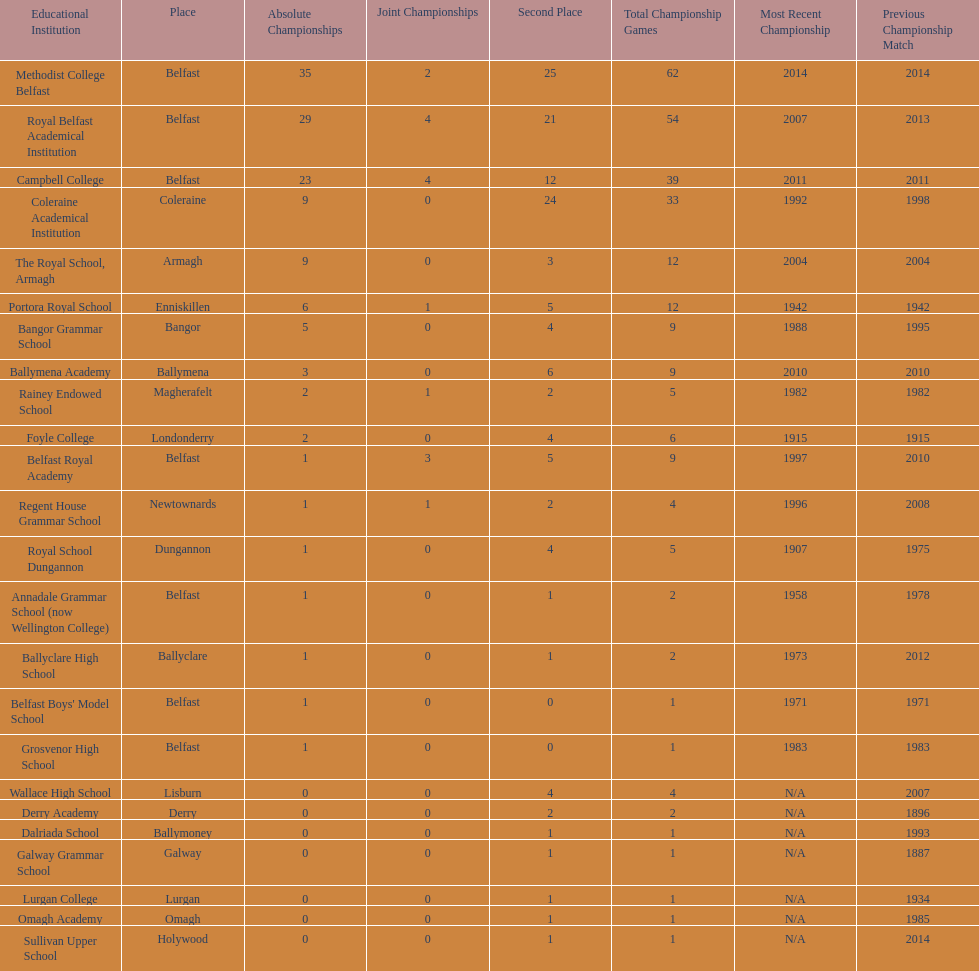What was the last year that the regent house grammar school won a title? 1996. 